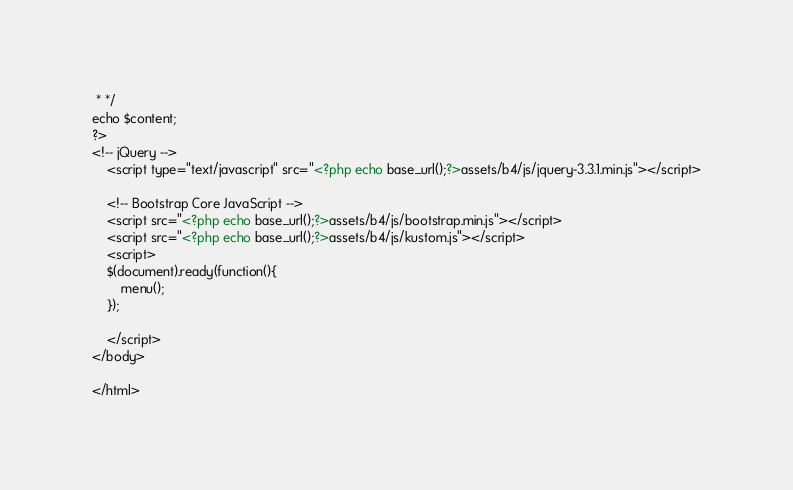<code> <loc_0><loc_0><loc_500><loc_500><_PHP_> * */
echo $content;
?>
<!-- jQuery -->
    <script type="text/javascript" src="<?php echo base_url();?>assets/b4/js/jquery-3.3.1.min.js"></script>

    <!-- Bootstrap Core JavaScript -->
    <script src="<?php echo base_url();?>assets/b4/js/bootstrap.min.js"></script>
    <script src="<?php echo base_url();?>assets/b4/js/kustom.js"></script>
    <script>
    $(document).ready(function(){
        menu();
    });

    </script>
</body>

</html></code> 